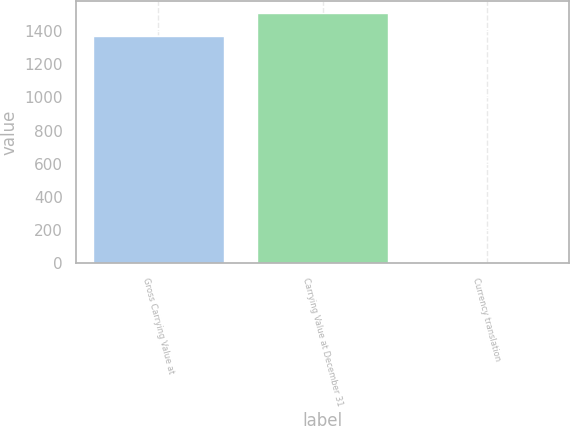<chart> <loc_0><loc_0><loc_500><loc_500><bar_chart><fcel>Gross Carrying Value at<fcel>Carrying Value at December 31<fcel>Currency translation<nl><fcel>1372.1<fcel>1509.42<fcel>0.5<nl></chart> 